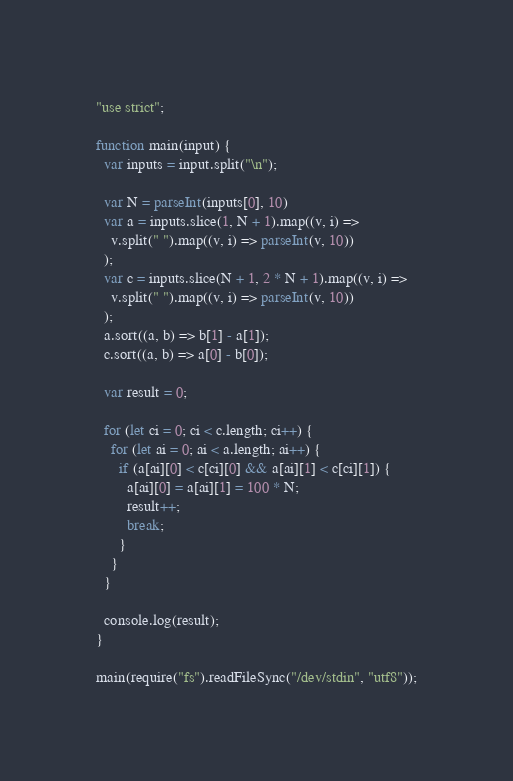Convert code to text. <code><loc_0><loc_0><loc_500><loc_500><_JavaScript_>"use strict";

function main(input) {
  var inputs = input.split("\n");

  var N = parseInt(inputs[0], 10)
  var a = inputs.slice(1, N + 1).map((v, i) =>
    v.split(" ").map((v, i) => parseInt(v, 10))
  );
  var c = inputs.slice(N + 1, 2 * N + 1).map((v, i) =>
    v.split(" ").map((v, i) => parseInt(v, 10))
  );
  a.sort((a, b) => b[1] - a[1]);
  c.sort((a, b) => a[0] - b[0]);

  var result = 0;

  for (let ci = 0; ci < c.length; ci++) {
    for (let ai = 0; ai < a.length; ai++) {
      if (a[ai][0] < c[ci][0] && a[ai][1] < c[ci][1]) {
        a[ai][0] = a[ai][1] = 100 * N;
        result++;
        break;
      }
    }
  }

  console.log(result);
}

main(require("fs").readFileSync("/dev/stdin", "utf8"));
</code> 